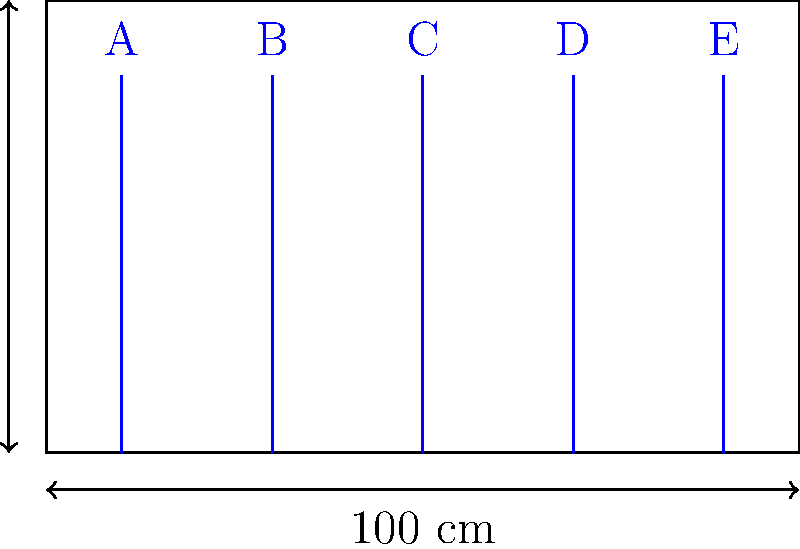A custom-built shelf for storing vinyl records measures 100 cm wide and 60 cm tall. If each record requires 2 cm of width for safe storage, and there's a 1 cm gap on each end of the shelf, what is the maximum number of records that can be stored while leaving at least 10 cm of vertical space for easy removal? Let's approach this step-by-step:

1. Calculate the available width for storing records:
   - Total width = 100 cm
   - Gaps on each end = 1 cm × 2 = 2 cm
   - Available width = 100 cm - 2 cm = 98 cm

2. Calculate the number of records that can fit horizontally:
   - Each record requires 2 cm
   - Number of records = Available width ÷ Width per record
   - Number of records = 98 cm ÷ 2 cm = 49 records

3. Check if there's enough vertical space:
   - Total height = 60 cm
   - Required space for easy removal = 10 cm
   - Available height for records = 60 cm - 10 cm = 50 cm

   Standard 12" vinyl records are approximately 30 cm in diameter, so 50 cm is sufficient for storing them vertically.

4. Verify the final count:
   The shelf can accommodate 49 records while meeting all the specified requirements.
Answer: 49 records 